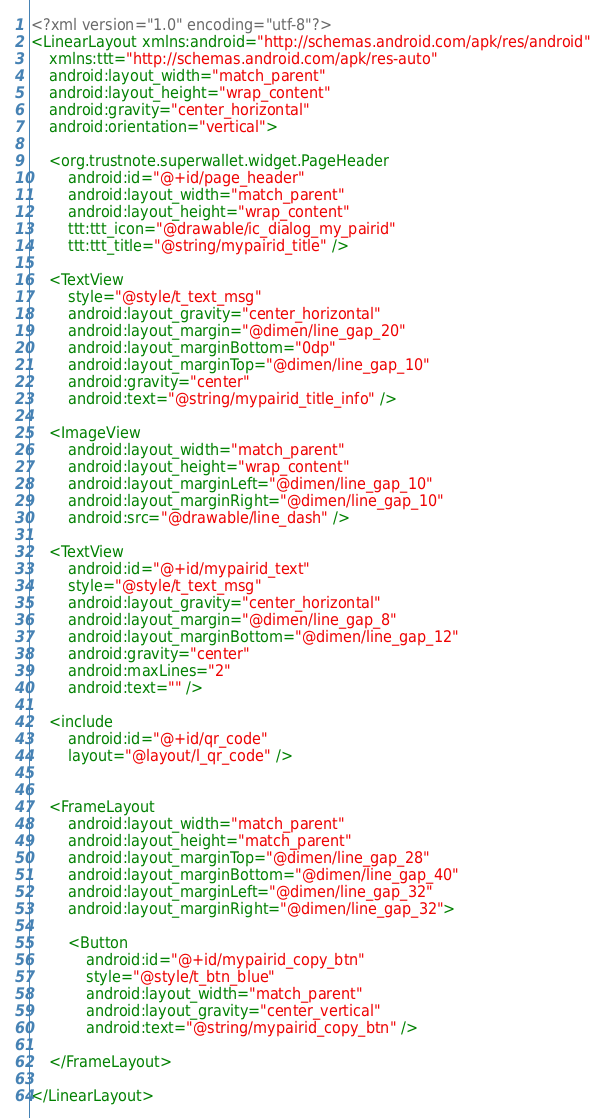<code> <loc_0><loc_0><loc_500><loc_500><_XML_><?xml version="1.0" encoding="utf-8"?>
<LinearLayout xmlns:android="http://schemas.android.com/apk/res/android"
    xmlns:ttt="http://schemas.android.com/apk/res-auto"
    android:layout_width="match_parent"
    android:layout_height="wrap_content"
    android:gravity="center_horizontal"
    android:orientation="vertical">

    <org.trustnote.superwallet.widget.PageHeader
        android:id="@+id/page_header"
        android:layout_width="match_parent"
        android:layout_height="wrap_content"
        ttt:ttt_icon="@drawable/ic_dialog_my_pairid"
        ttt:ttt_title="@string/mypairid_title" />

    <TextView
        style="@style/t_text_msg"
        android:layout_gravity="center_horizontal"
        android:layout_margin="@dimen/line_gap_20"
        android:layout_marginBottom="0dp"
        android:layout_marginTop="@dimen/line_gap_10"
        android:gravity="center"
        android:text="@string/mypairid_title_info" />

    <ImageView
        android:layout_width="match_parent"
        android:layout_height="wrap_content"
        android:layout_marginLeft="@dimen/line_gap_10"
        android:layout_marginRight="@dimen/line_gap_10"
        android:src="@drawable/line_dash" />

    <TextView
        android:id="@+id/mypairid_text"
        style="@style/t_text_msg"
        android:layout_gravity="center_horizontal"
        android:layout_margin="@dimen/line_gap_8"
        android:layout_marginBottom="@dimen/line_gap_12"
        android:gravity="center"
        android:maxLines="2"
        android:text="" />

    <include
        android:id="@+id/qr_code"
        layout="@layout/l_qr_code" />


    <FrameLayout
        android:layout_width="match_parent"
        android:layout_height="match_parent"
        android:layout_marginTop="@dimen/line_gap_28"
        android:layout_marginBottom="@dimen/line_gap_40"
        android:layout_marginLeft="@dimen/line_gap_32"
        android:layout_marginRight="@dimen/line_gap_32">

        <Button
            android:id="@+id/mypairid_copy_btn"
            style="@style/t_btn_blue"
            android:layout_width="match_parent"
            android:layout_gravity="center_vertical"
            android:text="@string/mypairid_copy_btn" />

    </FrameLayout>

</LinearLayout></code> 